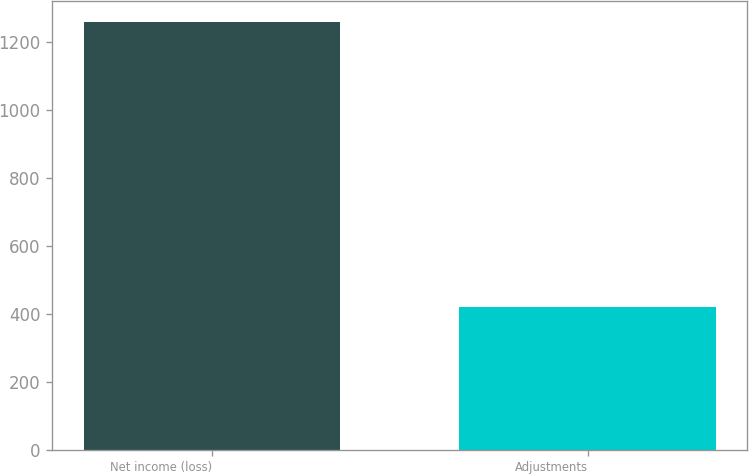Convert chart to OTSL. <chart><loc_0><loc_0><loc_500><loc_500><bar_chart><fcel>Net income (loss)<fcel>Adjustments<nl><fcel>1259<fcel>419<nl></chart> 